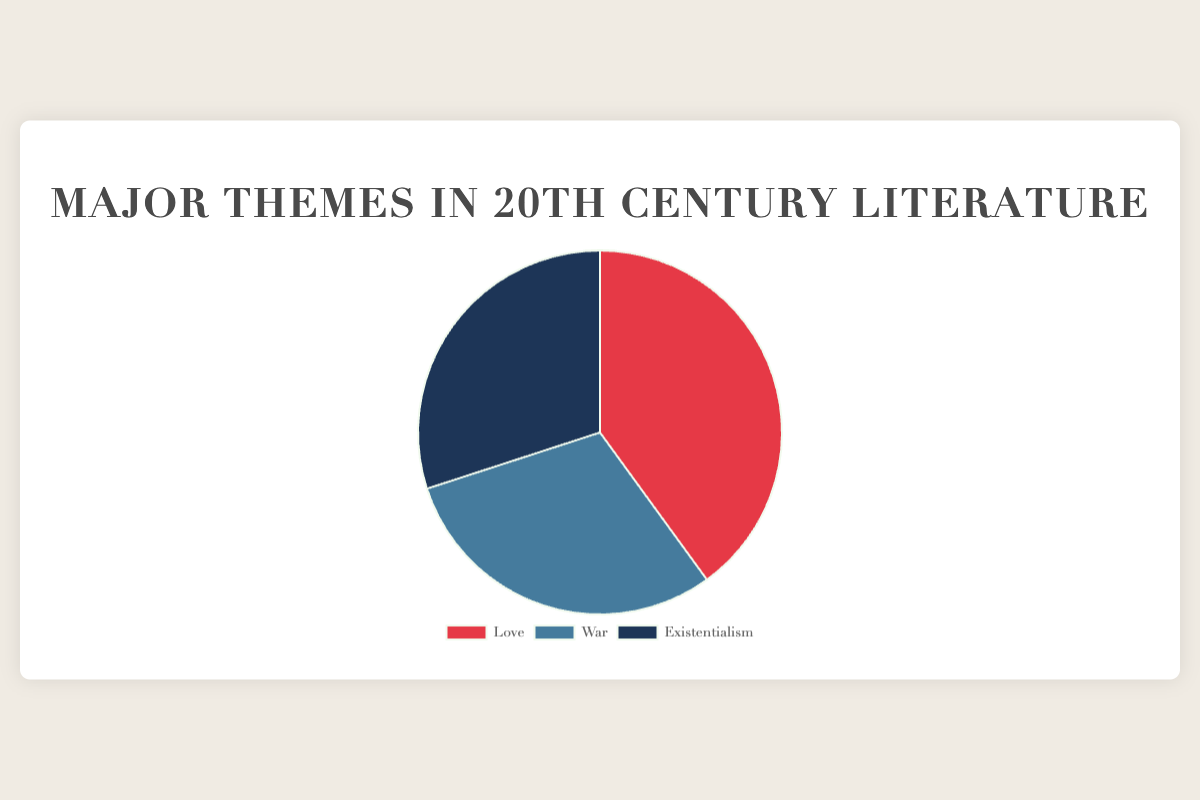Which theme occupies the largest portion of the chart? The theme that occupies the largest portion can be identified by looking at the size of the pie slices. Love, with 40%, is larger than War and Existentialism, each of which is 30%.
Answer: Love Which two themes have equal portions in the pie chart? To determine the themes with equal portions, we compare the percentages. War and Existentialism both have 30%.
Answer: War and Existentialism What is the combined percentage of the themes War and Existentialism? Adding the percentages for War (30%) and Existentialism (30%) gives a combined total of 30 + 30 = 60%.
Answer: 60% How much larger is the Love theme compared to the War theme? Subtract the percentage of War (30%) from the percentage of Love (40%) to find the difference: 40 - 30 = 10%.
Answer: 10% Which theme is represented by the reddest section in the chart? By identifying the color associated with each theme, we see that the reddest section corresponds to Love, which is represented in red.
Answer: Love What is the average percentage of all three themes? First, sum all the percentages: 40 (Love) + 30 (War) + 30 (Existentialism) = 100. Then, divide by the number of themes: 100 / 3 ≈ 33.33%.
Answer: 33.33% If the chart were to be divided into two parts, with Love on one side and War and Existentialism combined on the other, which side would be larger? Adding the percentages of War (30%) and Existentialism (30%) gives 60%, which is larger than Love's 40%.
Answer: War and Existentialism What is the difference in percentage between the smallest and largest themes? The smallest themes are War and Existentialism, each with 30%. The largest theme is Love with 40%. The difference is 40% - 30% = 10%.
Answer: 10% Which color in the chart represents the theme Existentialism? The by chart's color coding, Existentialism is represented by the dark blue section.
Answer: Dark blue 